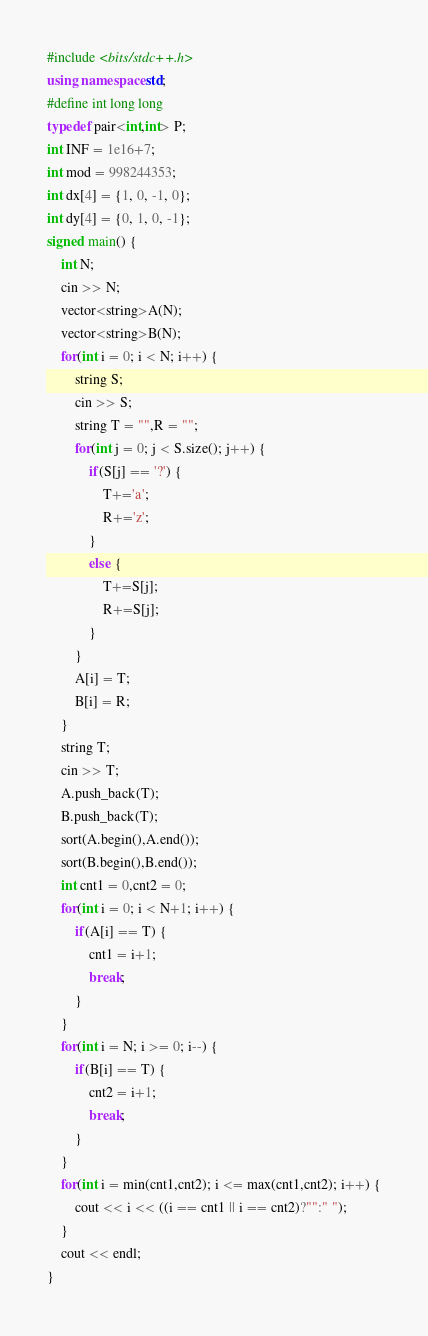Convert code to text. <code><loc_0><loc_0><loc_500><loc_500><_C++_>#include <bits/stdc++.h>
using namespace std;
#define int long long
typedef pair<int,int> P;
int INF = 1e16+7;
int mod = 998244353;
int dx[4] = {1, 0, -1, 0};
int dy[4] = {0, 1, 0, -1};
signed main() {
    int N;
    cin >> N;
    vector<string>A(N);
    vector<string>B(N);
    for(int i = 0; i < N; i++) {
        string S;
        cin >> S;
        string T = "",R = "";
        for(int j = 0; j < S.size(); j++) {
            if(S[j] == '?') {
                T+='a';
                R+='z';
            }
            else {
                T+=S[j];
                R+=S[j];
            }
        }
        A[i] = T;
        B[i] = R;
    }
    string T;
    cin >> T;
    A.push_back(T);
    B.push_back(T);
    sort(A.begin(),A.end());
    sort(B.begin(),B.end());
    int cnt1 = 0,cnt2 = 0;
    for(int i = 0; i < N+1; i++) {
        if(A[i] == T) {
            cnt1 = i+1;
            break;
        }
    }
    for(int i = N; i >= 0; i--) {
        if(B[i] == T) {
            cnt2 = i+1;
            break;
        }
    }
    for(int i = min(cnt1,cnt2); i <= max(cnt1,cnt2); i++) {
        cout << i << ((i == cnt1 || i == cnt2)?"":" ");
    }
    cout << endl;
}
</code> 